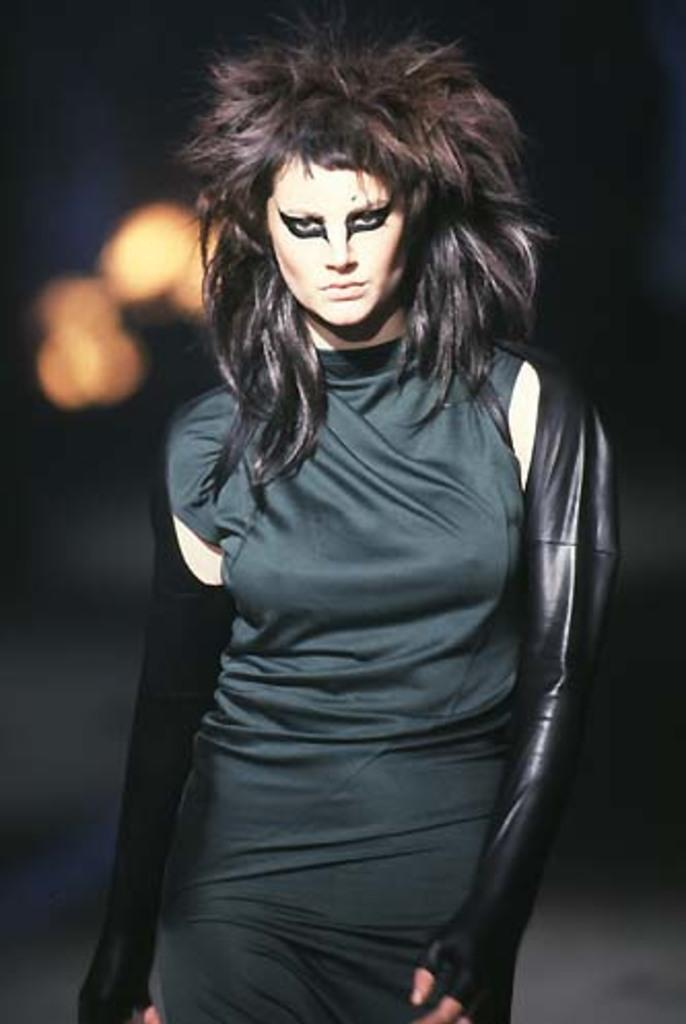Who is present in the image? There is a woman in the image. What is the woman doing in the image? The woman is standing. What is the woman wearing in the image? The woman is wearing a black dress. What can be seen in the background of the image? There is a light visible in the background of the image. What type of produce is the woman holding in the image? There is no produce present in the image; the woman is not holding anything. 